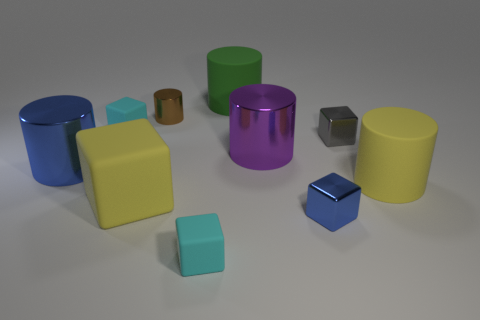Subtract all cyan cubes. How many were subtracted if there are1cyan cubes left? 1 Subtract all big cubes. How many cubes are left? 4 Subtract all purple cylinders. How many cylinders are left? 4 Subtract all purple blocks. Subtract all gray cylinders. How many blocks are left? 5 Add 4 yellow things. How many yellow things are left? 6 Add 9 cyan metal cylinders. How many cyan metal cylinders exist? 9 Subtract 0 red blocks. How many objects are left? 10 Subtract all small brown shiny cylinders. Subtract all tiny cyan rubber cubes. How many objects are left? 7 